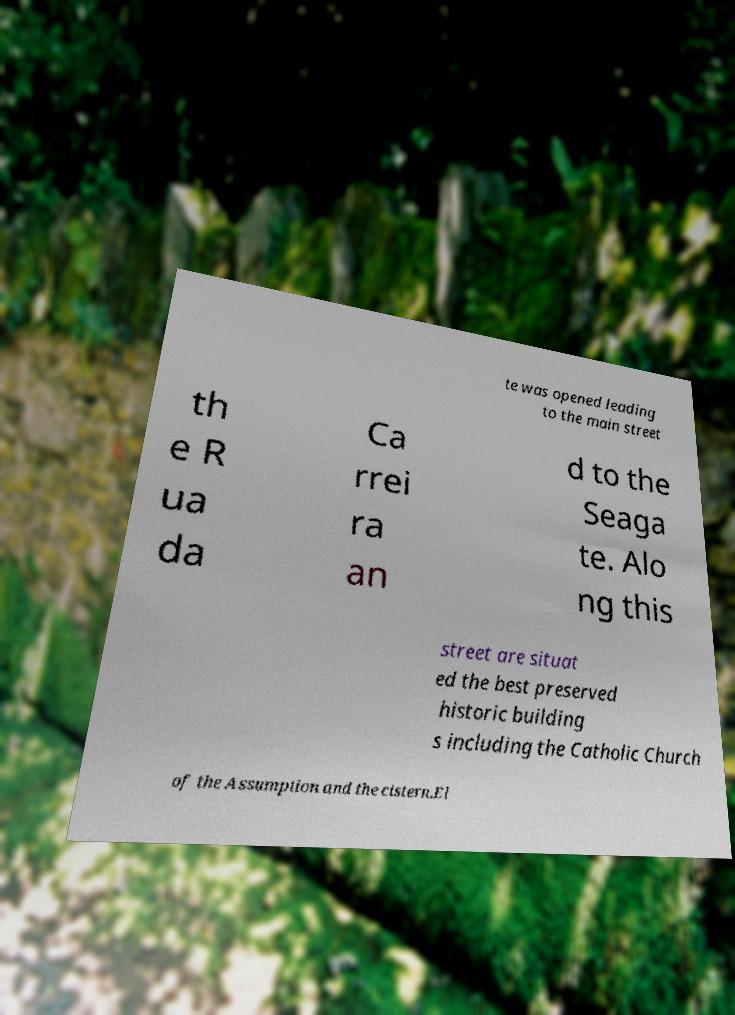For documentation purposes, I need the text within this image transcribed. Could you provide that? te was opened leading to the main street th e R ua da Ca rrei ra an d to the Seaga te. Alo ng this street are situat ed the best preserved historic building s including the Catholic Church of the Assumption and the cistern.El 